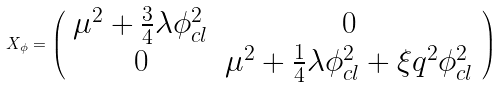<formula> <loc_0><loc_0><loc_500><loc_500>X _ { \phi } = \left ( \begin{array} { c c } { { \mu ^ { 2 } + \frac { 3 } { 4 } \lambda \phi _ { c l } ^ { 2 } } } & { 0 } \\ { 0 } & { { \mu ^ { 2 } + \frac { 1 } { 4 } \lambda \phi _ { c l } ^ { 2 } + \xi q ^ { 2 } \phi _ { c l } ^ { 2 } } } \end{array} \right )</formula> 